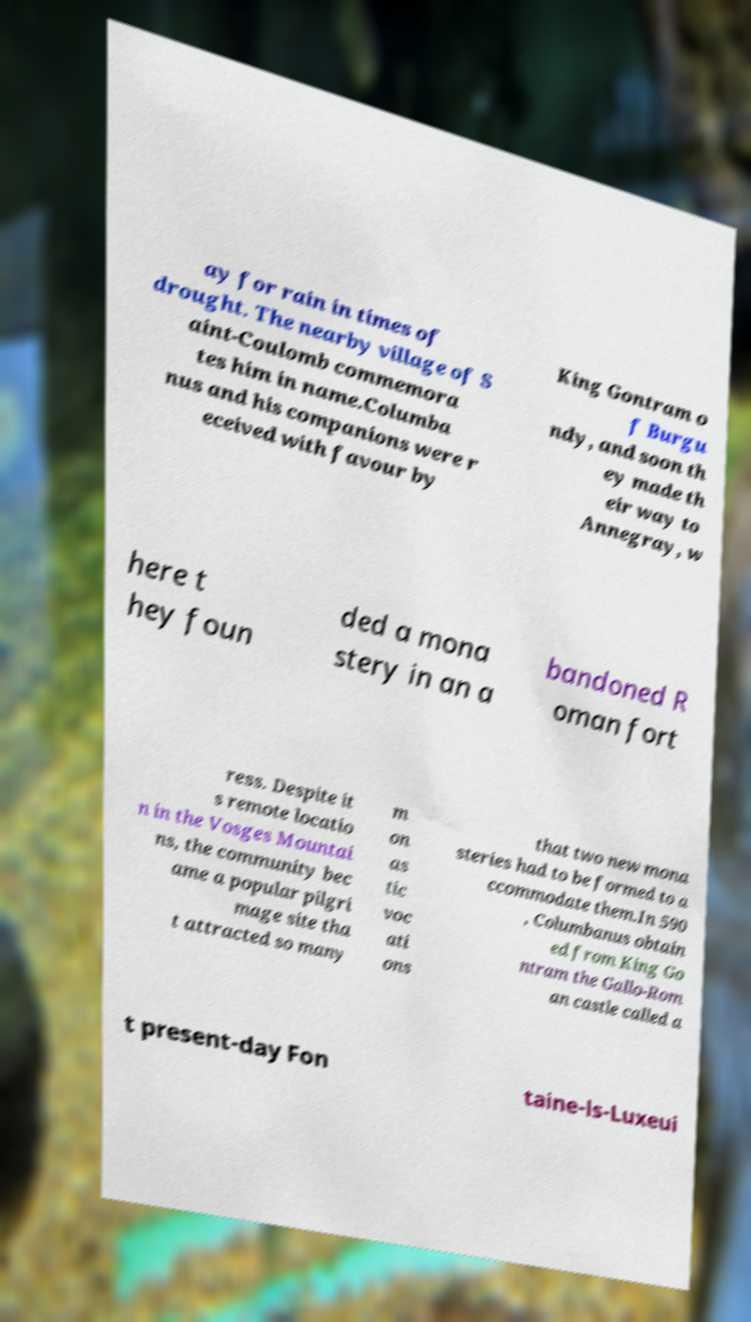Could you assist in decoding the text presented in this image and type it out clearly? ay for rain in times of drought. The nearby village of S aint-Coulomb commemora tes him in name.Columba nus and his companions were r eceived with favour by King Gontram o f Burgu ndy, and soon th ey made th eir way to Annegray, w here t hey foun ded a mona stery in an a bandoned R oman fort ress. Despite it s remote locatio n in the Vosges Mountai ns, the community bec ame a popular pilgri mage site tha t attracted so many m on as tic voc ati ons that two new mona steries had to be formed to a ccommodate them.In 590 , Columbanus obtain ed from King Go ntram the Gallo-Rom an castle called a t present-day Fon taine-ls-Luxeui 